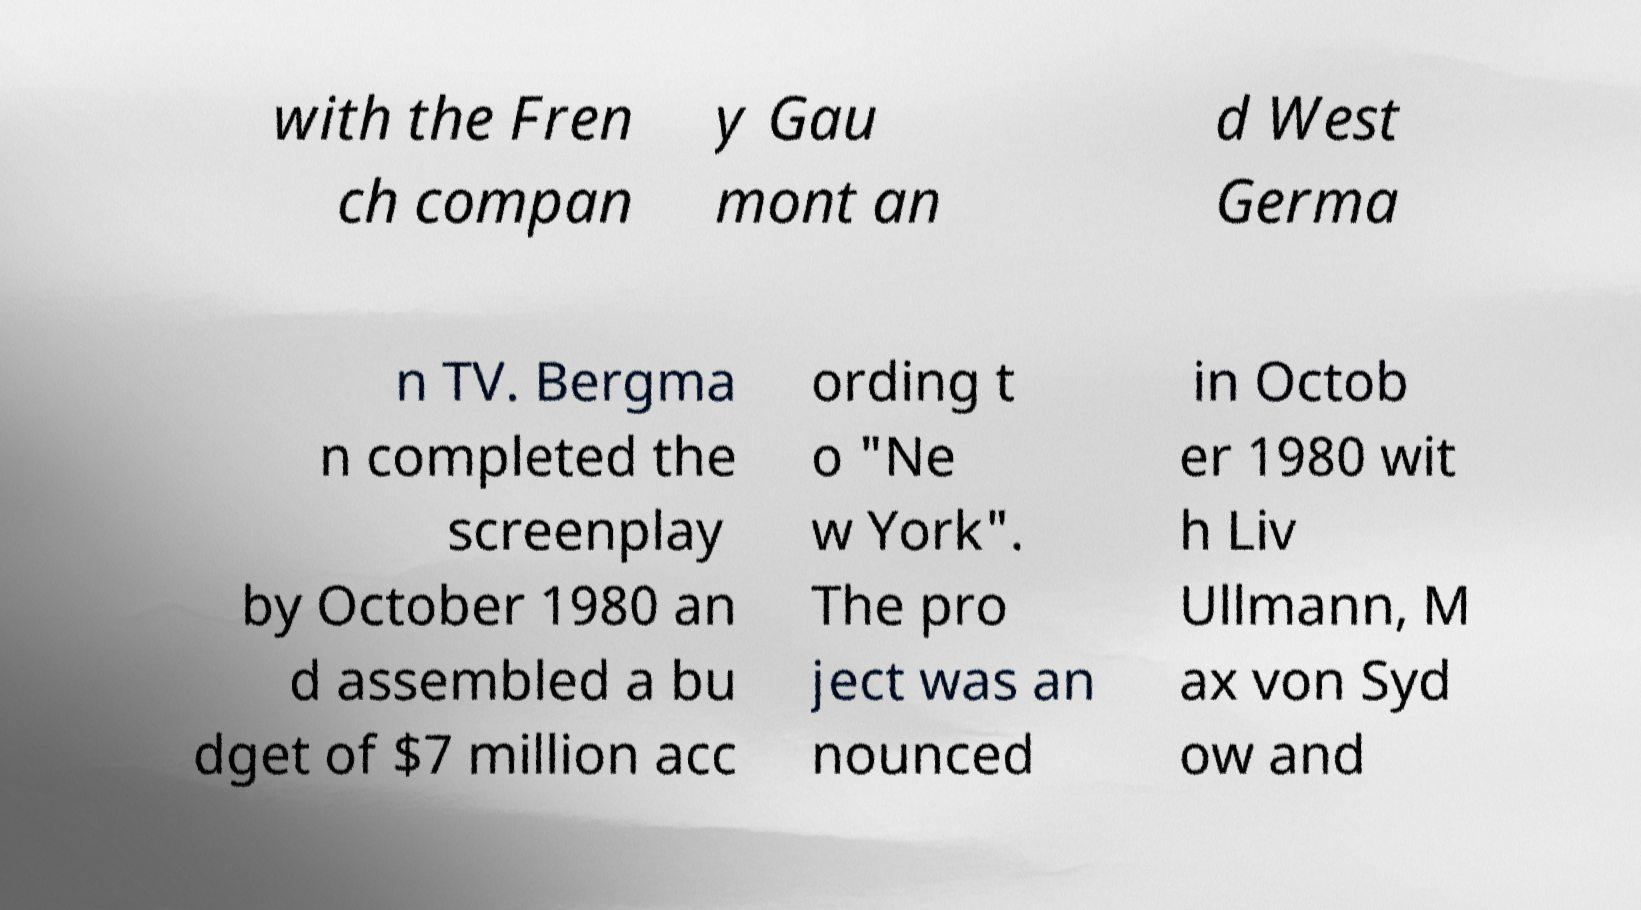For documentation purposes, I need the text within this image transcribed. Could you provide that? with the Fren ch compan y Gau mont an d West Germa n TV. Bergma n completed the screenplay by October 1980 an d assembled a bu dget of $7 million acc ording t o "Ne w York". The pro ject was an nounced in Octob er 1980 wit h Liv Ullmann, M ax von Syd ow and 